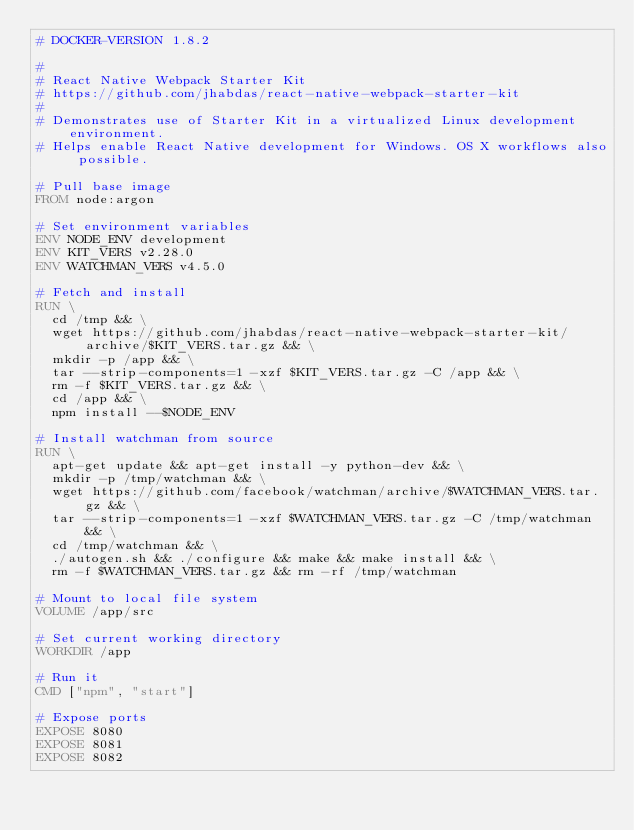Convert code to text. <code><loc_0><loc_0><loc_500><loc_500><_Dockerfile_># DOCKER-VERSION 1.8.2

#
# React Native Webpack Starter Kit
# https://github.com/jhabdas/react-native-webpack-starter-kit
#
# Demonstrates use of Starter Kit in a virtualized Linux development environment.
# Helps enable React Native development for Windows. OS X workflows also possible.

# Pull base image
FROM node:argon

# Set environment variables
ENV NODE_ENV development
ENV KIT_VERS v2.28.0
ENV WATCHMAN_VERS v4.5.0

# Fetch and install
RUN \
  cd /tmp && \
  wget https://github.com/jhabdas/react-native-webpack-starter-kit/archive/$KIT_VERS.tar.gz && \
  mkdir -p /app && \
  tar --strip-components=1 -xzf $KIT_VERS.tar.gz -C /app && \
  rm -f $KIT_VERS.tar.gz && \
  cd /app && \
  npm install --$NODE_ENV

# Install watchman from source
RUN \
  apt-get update && apt-get install -y python-dev && \
  mkdir -p /tmp/watchman && \
  wget https://github.com/facebook/watchman/archive/$WATCHMAN_VERS.tar.gz && \
  tar --strip-components=1 -xzf $WATCHMAN_VERS.tar.gz -C /tmp/watchman && \
  cd /tmp/watchman && \
  ./autogen.sh && ./configure && make && make install && \
  rm -f $WATCHMAN_VERS.tar.gz && rm -rf /tmp/watchman

# Mount to local file system
VOLUME /app/src

# Set current working directory
WORKDIR /app

# Run it
CMD ["npm", "start"]

# Expose ports
EXPOSE 8080
EXPOSE 8081
EXPOSE 8082
</code> 